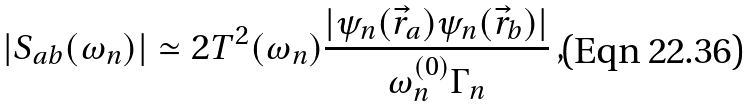<formula> <loc_0><loc_0><loc_500><loc_500>| S _ { a b } ( \omega _ { n } ) | \simeq 2 T ^ { 2 } ( \omega _ { n } ) \frac { | \psi _ { n } ( \vec { r } _ { a } ) \psi _ { n } ( \vec { r } _ { b } ) | } { \omega ^ { ( 0 ) } _ { n } \Gamma _ { n } } \, ,</formula> 